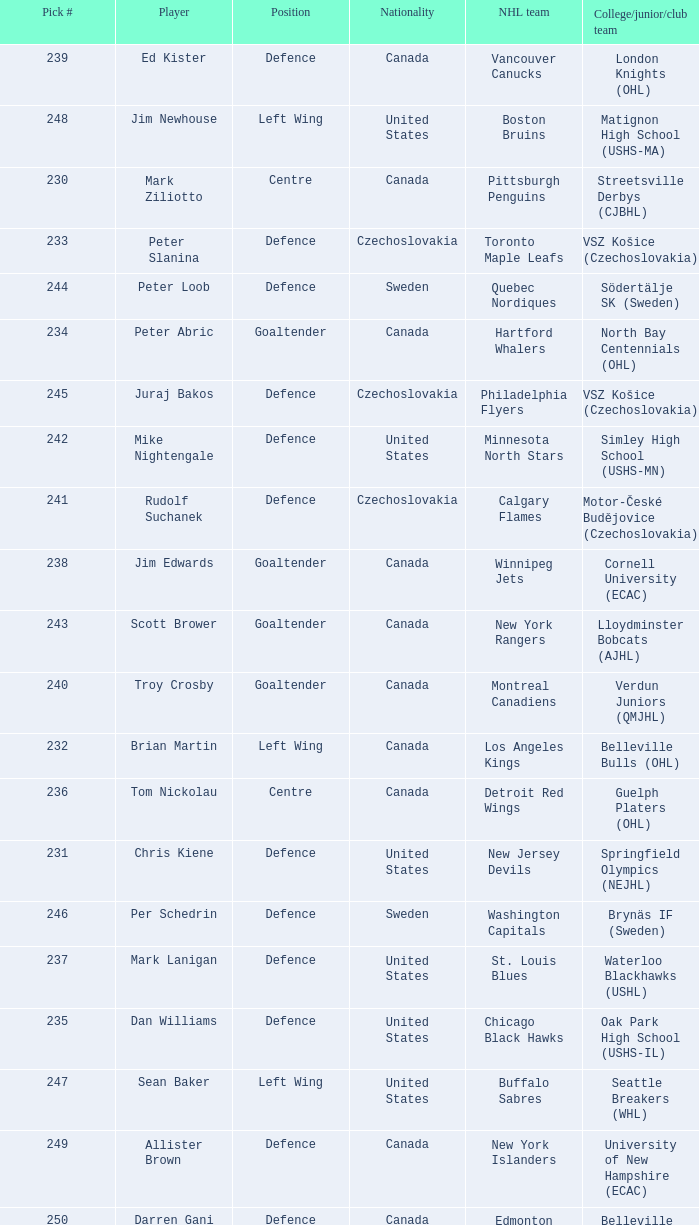What selection was the springfield olympics (nejhl)? 231.0. 